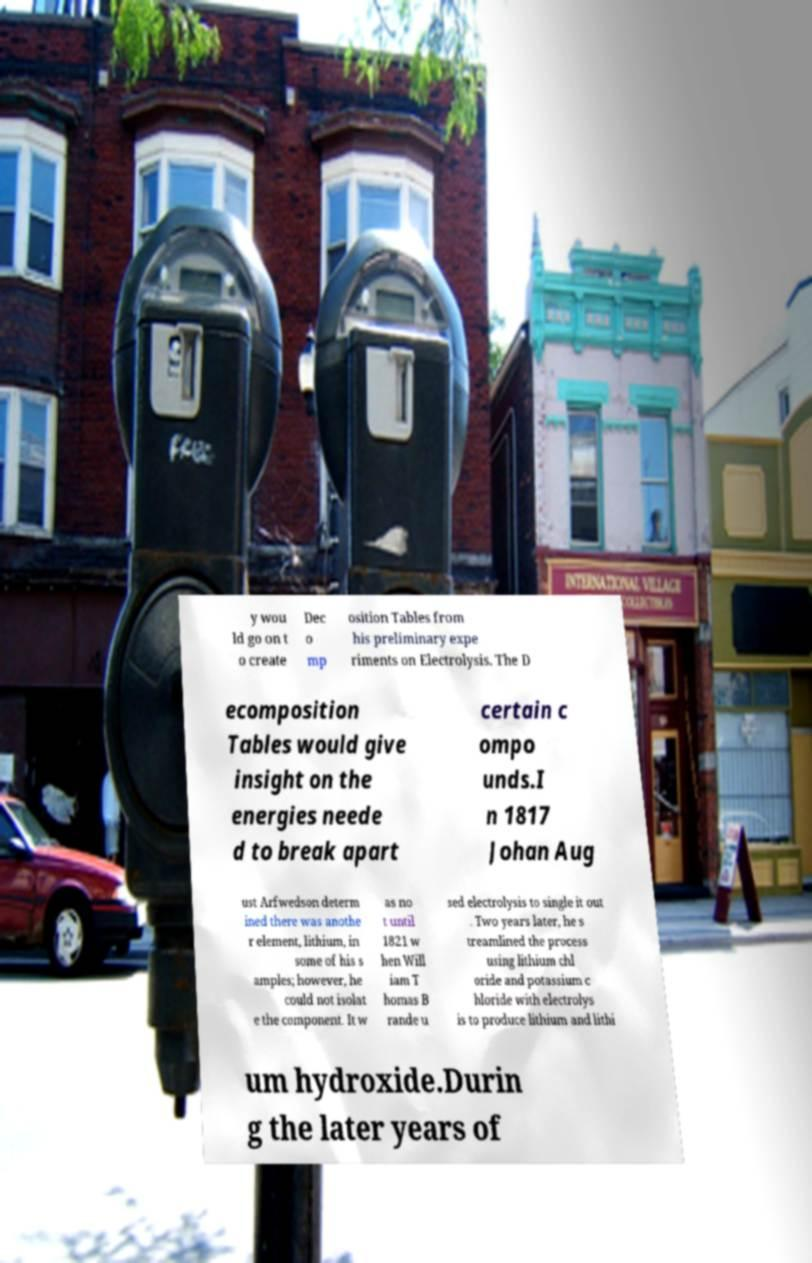What messages or text are displayed in this image? I need them in a readable, typed format. y wou ld go on t o create Dec o mp osition Tables from his preliminary expe riments on Electrolysis. The D ecomposition Tables would give insight on the energies neede d to break apart certain c ompo unds.I n 1817 Johan Aug ust Arfwedson determ ined there was anothe r element, lithium, in some of his s amples; however, he could not isolat e the component. It w as no t until 1821 w hen Will iam T homas B rande u sed electrolysis to single it out . Two years later, he s treamlined the process using lithium chl oride and potassium c hloride with electrolys is to produce lithium and lithi um hydroxide.Durin g the later years of 